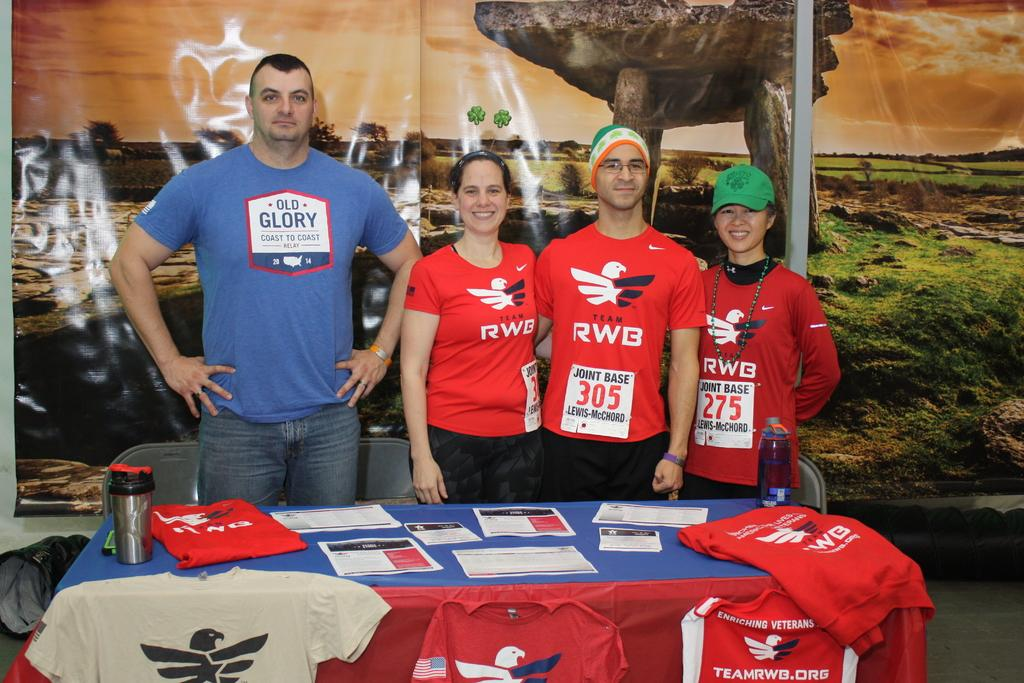<image>
Summarize the visual content of the image. The sponsor of the athletes is Team RWB. 